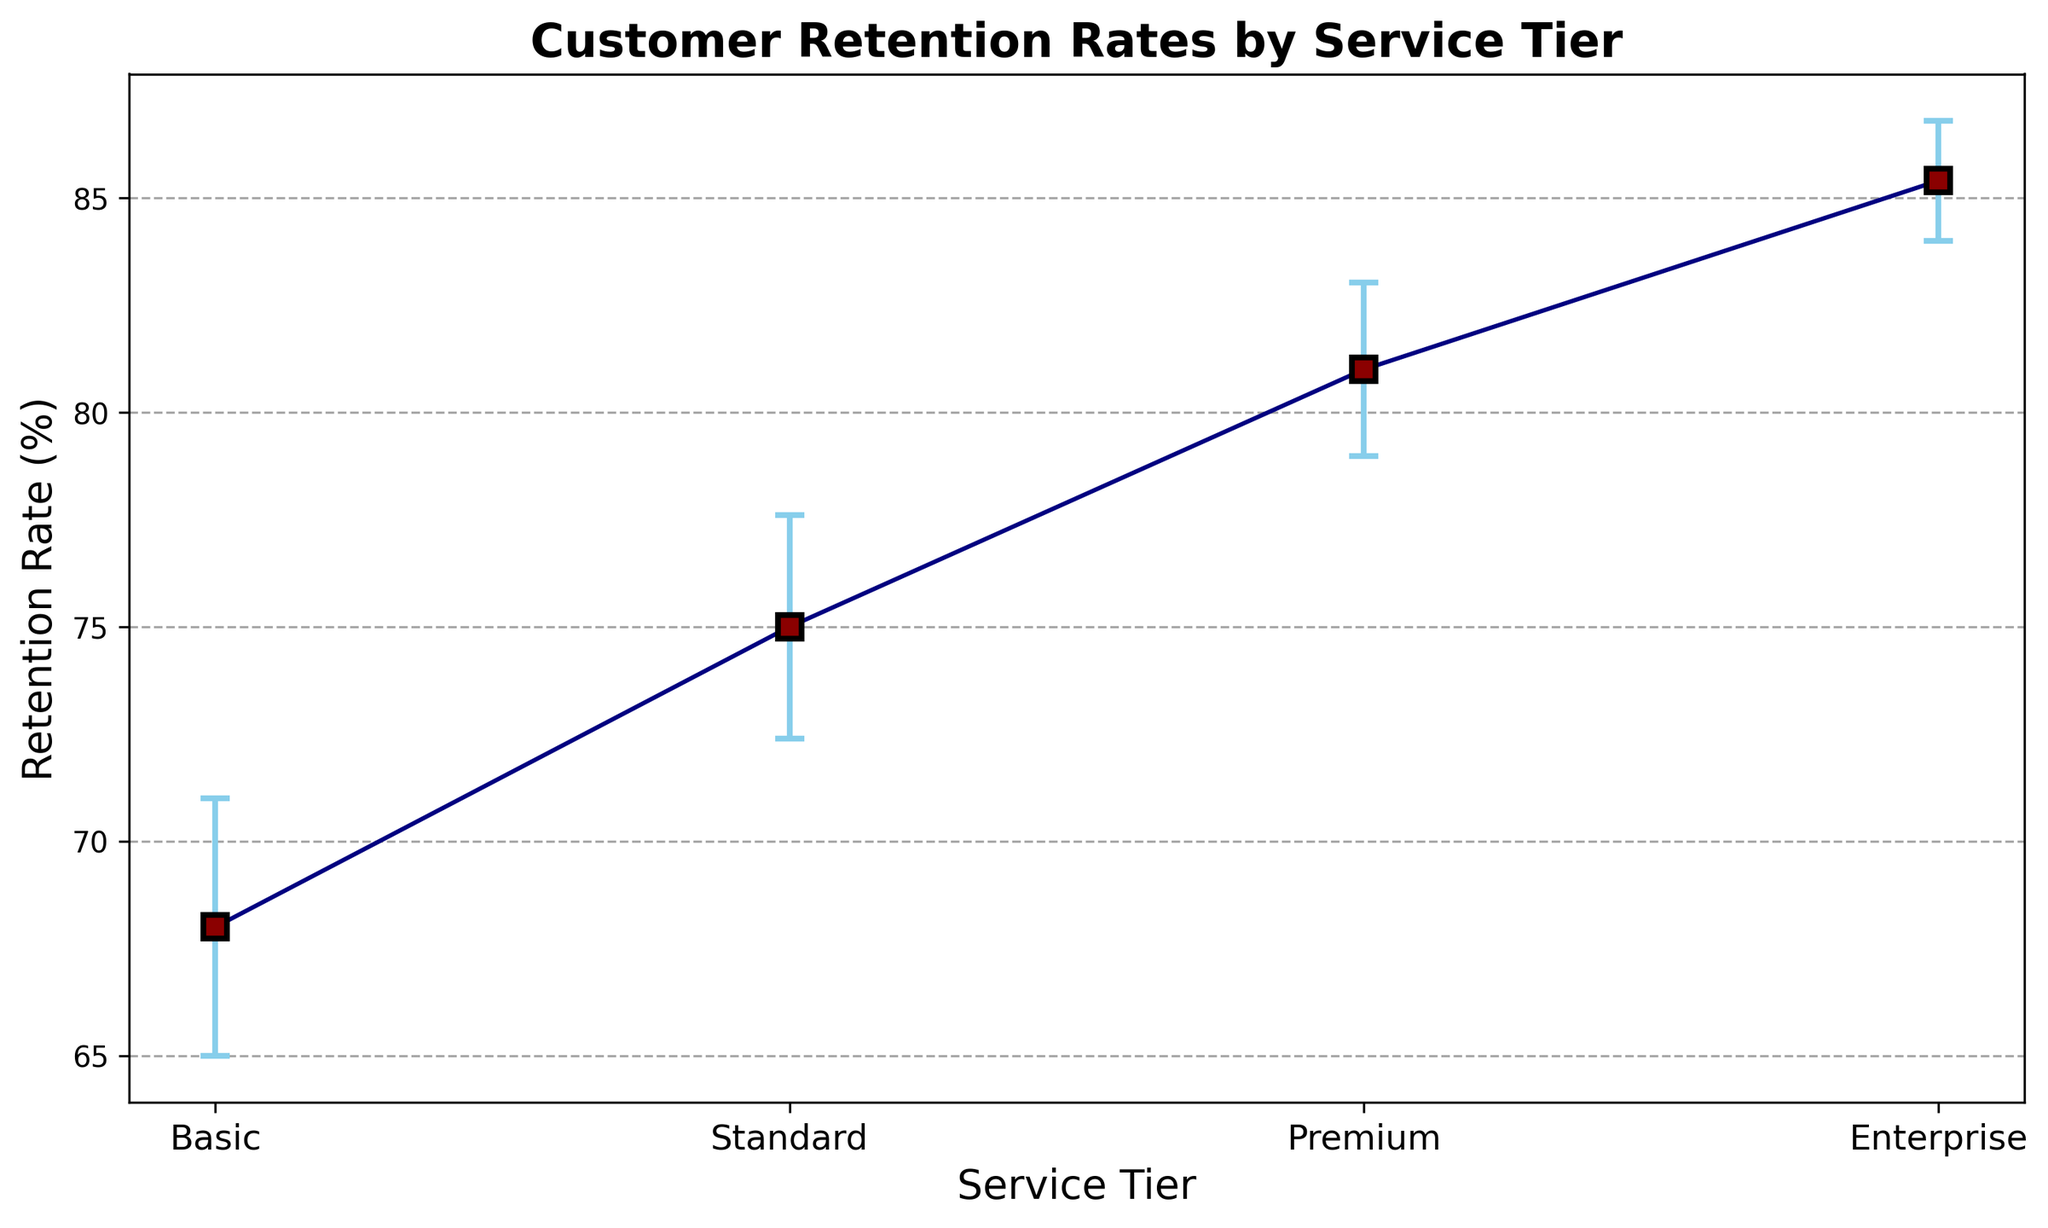What is the retention rate for the Premium service tier? From the plot, identify the data point corresponding to the Premium service tier, which is visually displayed.
Answer: 81% How does the retention rate for the Basic tier compare to the Enterprise tier? Compare the retention rate values of the Basic and Enterprise tiers in the figure. Basic: ~68%, Enterprise: ~85%.
Answer: The retention rate for the Enterprise tier is higher by ~17% Which service tier has the highest retention rate? Look for the tallest data point in the figure. The Enterprise tier has the highest retention rate.
Answer: Enterprise What is the difference in retention rates between the Standard and Premium tiers? Identify the retention rates from the plot: Standard ~75%, Premium ~81%, and calculate the difference: 81% - 75% = 6%.
Answer: 6% Which service tier exhibits the smallest standard error in retention rates? Identify the smallest error bar in the figure, which corresponds to the standard error. The Enterprise tier has the smallest error bar.
Answer: Enterprise What is the average retention rate across all service tiers? Compute the mean of the retention rates for all tiers: (68 + 75 + 81 + 85) / 4 = 77.25%.
Answer: 77.25% How does the variation in retention rates for the Basic tier compare to the Premium tier? Visualize the lengths of the error bars for both tiers. The Basic tier has longer error bars, hence higher variation.
Answer: Basic has more variation What is the range (difference between the maximum and minimum) of the average retention rates across service tiers? Calculate the range by finding the difference between the maximum and minimum average retention rates: 85% - 68% = 17%.
Answer: 17% Which service tier shows the most consistency in retention rates, based on their standard error? Identify the service tier with the smallest error bars, indicating consistency. The Enterprise tier has the smallest error bars.
Answer: Enterprise 